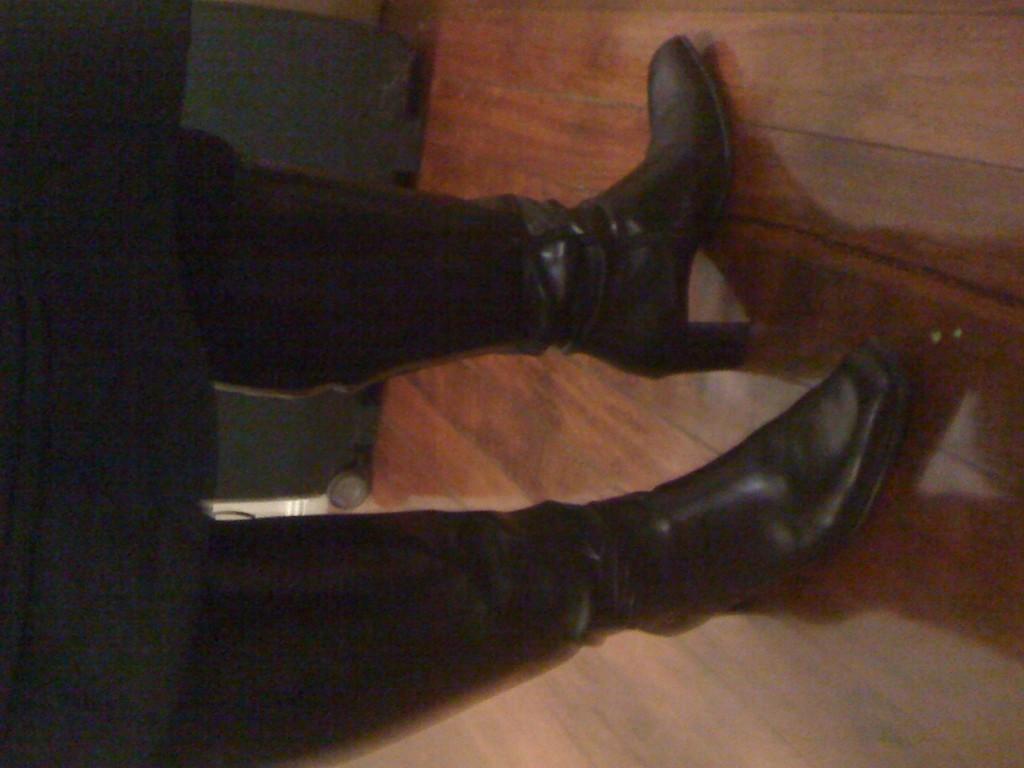Can you describe this image briefly? In this image there is one person wearing a black color shoe and standing on a wooden floor in the middle of this image. 